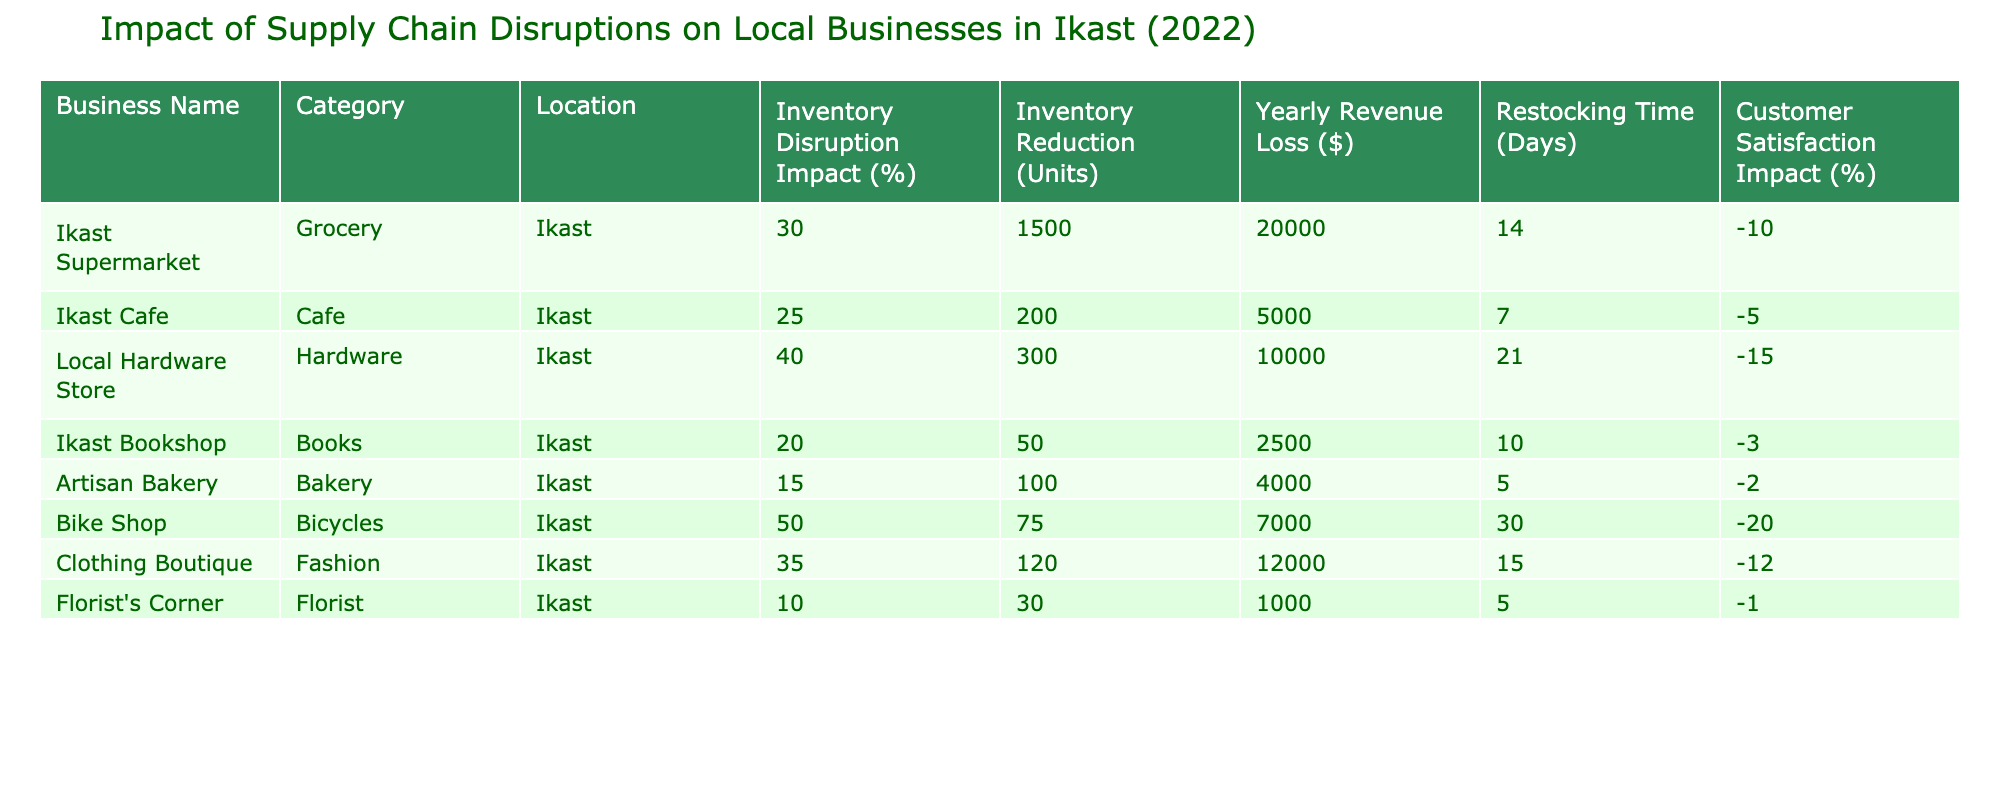What is the inventory disruption impact percentage for the Local Hardware Store? The table lists the "Inventory Disruption Impact (%)" for the Local Hardware Store as 40%.
Answer: 40% Which business experienced the highest yearly revenue loss? By scanning the "Yearly Revenue Loss ($)" column, the Ikast Supermarket shows the highest revenue loss of $20,000.
Answer: Ikast Supermarket What is the total inventory reduction in units for all businesses combined? By adding the "Inventory Reduction (Units)" for each business, we get 1500 + 200 + 300 + 50 + 100 + 75 + 120 + 30 = 2375 units.
Answer: 2375 units Did the Florist's Corner experience a positive customer satisfaction impact? The "Customer Satisfaction Impact (%)" for the Florist's Corner is -1%, which indicates a negative impact.
Answer: No What is the average restocking time (in days) for the businesses listed in the table? First, sum the "Restocking Time (Days)" values: 14 + 7 + 21 + 10 + 5 + 30 + 15 + 5 = 107 days. With 8 businesses, the average is 107 / 8 = 13.375.
Answer: 13.375 days Which business had the lowest inventory disruption impact percentage? The table shows that the Florist's Corner has the lowest disruption impact at 10%, making it the business with the least impact.
Answer: Florist's Corner What is the difference in inventory disruption impact between the Bike Shop and the Clothing Boutique? The Bike Shop has a disruption impact of 50%, while the Clothing Boutique has 35%. Therefore, the difference is 50% - 35% = 15%.
Answer: 15% Is there any business with a restocking time of fewer than 10 days? Both the Ikast Cafe (7 days) and the Artisan Bakery (5 days) have restocking times under 10 days, indicating that yes, there are businesses with a shorter restocking time.
Answer: Yes 